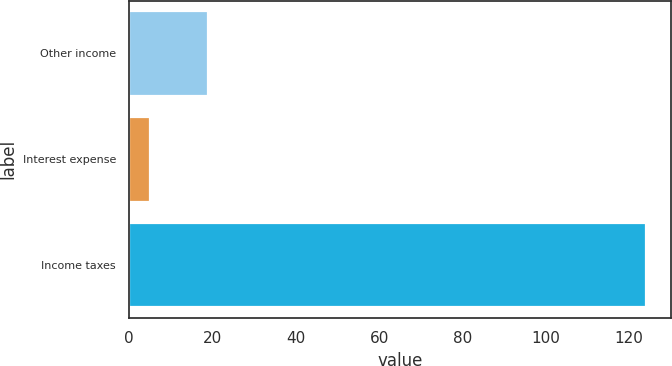Convert chart to OTSL. <chart><loc_0><loc_0><loc_500><loc_500><bar_chart><fcel>Other income<fcel>Interest expense<fcel>Income taxes<nl><fcel>19<fcel>5<fcel>124<nl></chart> 